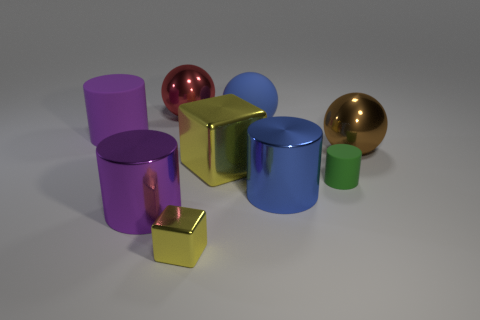Is the material of the yellow thing left of the large yellow cube the same as the large yellow block?
Your response must be concise. Yes. Is there any other thing that has the same material as the large brown ball?
Keep it short and to the point. Yes. What size is the rubber cylinder that is to the right of the thing that is to the left of the purple shiny cylinder?
Keep it short and to the point. Small. What is the size of the metal sphere on the left side of the blue object that is behind the yellow shiny object that is behind the blue metallic object?
Give a very brief answer. Large. There is a big blue object that is in front of the big brown shiny thing; is it the same shape as the large matte object in front of the large blue sphere?
Make the answer very short. Yes. How many other objects are the same color as the tiny cube?
Offer a very short reply. 1. Is the size of the purple thing that is behind the purple metal cylinder the same as the big red thing?
Offer a very short reply. Yes. Are the large sphere that is left of the rubber ball and the yellow thing on the right side of the tiny yellow thing made of the same material?
Give a very brief answer. Yes. Is there a blue object of the same size as the purple matte thing?
Provide a short and direct response. Yes. The small thing that is left of the big blue thing that is behind the purple object behind the green rubber cylinder is what shape?
Provide a succinct answer. Cube. 